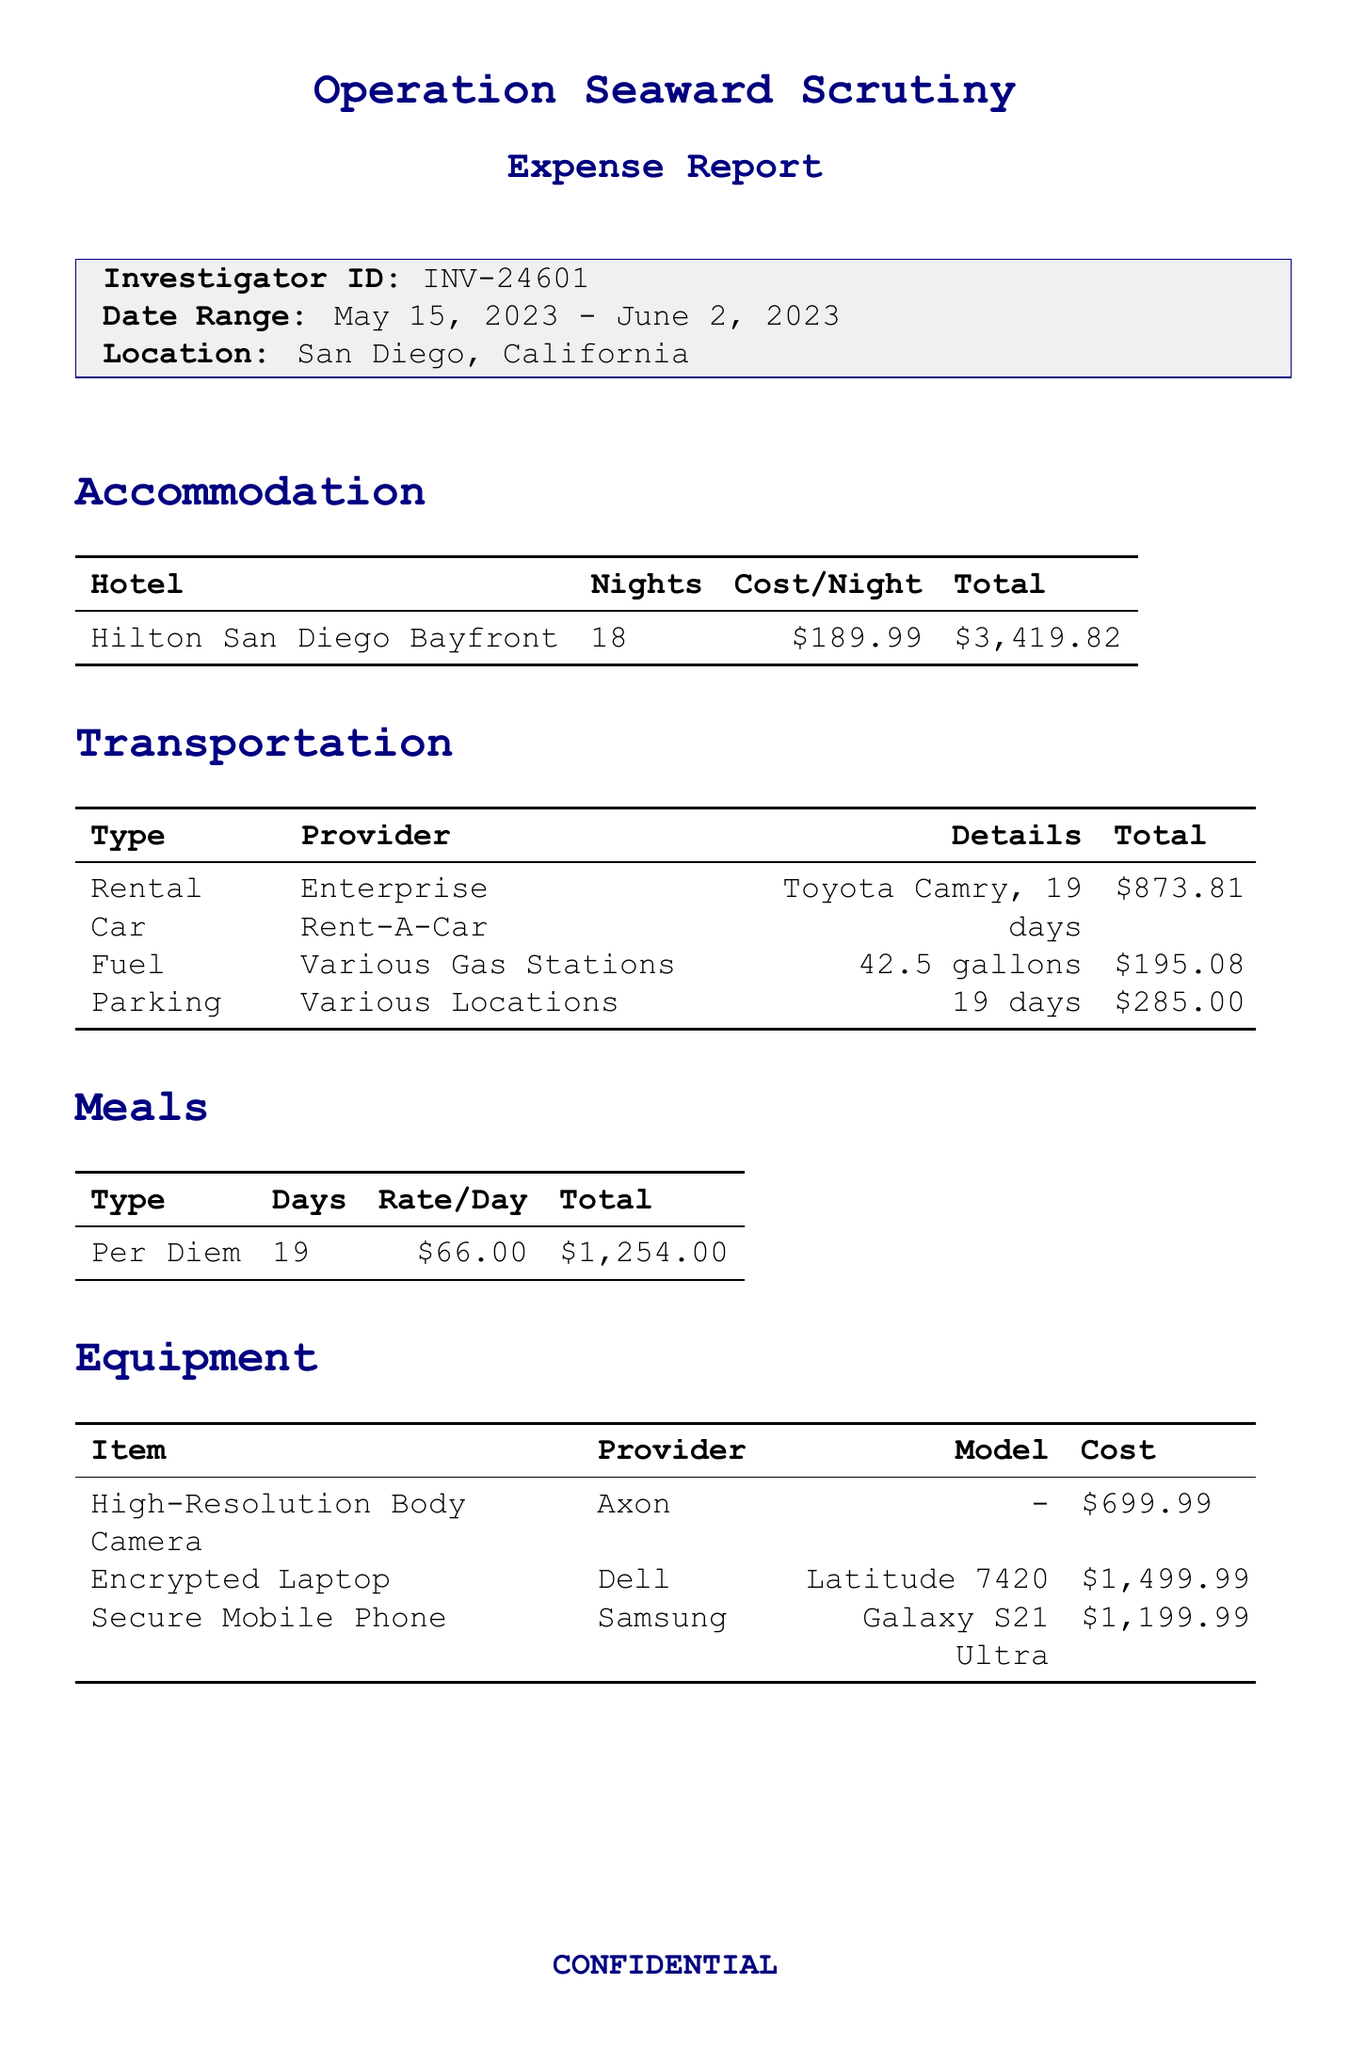what is the operation name? The operation name is provided at the top of the document, detailing the purpose of the expense report.
Answer: Operation Seaward Scrutiny who is the investigator? The investigator ID is listed in the document, indicating the individual responsible for the operation.
Answer: INV-24601 what is the total cost for accommodation? The accommodation section summarizes the total cost incurred for staying at the hotel during the operation.
Answer: $3419.82 how many nights did the investigator stay at the hotel? This information can be found in the accommodation section, indicating the duration of the hotel stay.
Answer: 18 what were the transportation costs in total? All transportation-related expenses are summed up in the transportation section of the report.
Answer: $1,353.89 how much was spent on meals? The meals section provides the total expenditure for meals during the operation.
Answer: $1,254.00 what is the total amount spent on equipment? The equipment section details the costs associated with necessary equipment for the operation, which can be summed up for the total.
Answer: $3,399.97 what was the daily cost of parking? The document specifies the rate charged per day for parking services utilized during the operation.
Answer: $15.00 what is the overall total of expenses? The total expenses summary at the end of the document presents the cumulative cost of all incurred expenses during the operation.
Answer: $10,957.68 